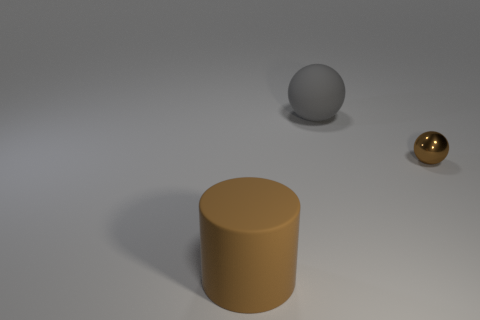Is there any other thing that is the same size as the metallic sphere?
Keep it short and to the point. No. Are there any other things that have the same material as the brown sphere?
Make the answer very short. No. Is there any other thing that has the same shape as the brown matte thing?
Ensure brevity in your answer.  No. What number of things are rubber objects that are behind the metallic ball or large gray rubber things?
Offer a very short reply. 1. What number of other things are the same shape as the metal object?
Provide a short and direct response. 1. There is a thing right of the big gray matte thing; is its shape the same as the big gray rubber object?
Give a very brief answer. Yes. There is a gray rubber thing; are there any large cylinders in front of it?
Provide a succinct answer. Yes. What number of tiny things are brown rubber spheres or matte things?
Make the answer very short. 0. Are the big gray ball and the brown sphere made of the same material?
Your answer should be compact. No. What size is the sphere that is the same color as the big rubber cylinder?
Your response must be concise. Small. 